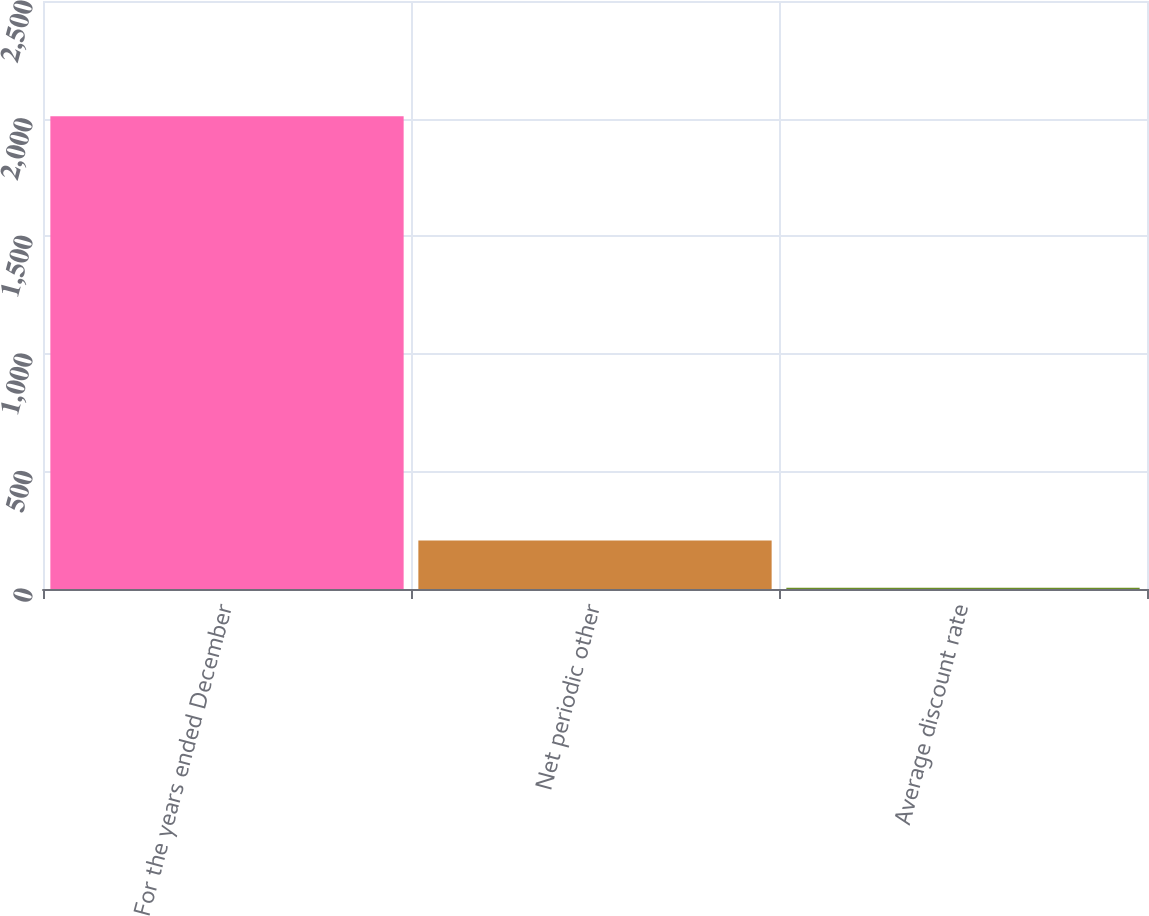Convert chart. <chart><loc_0><loc_0><loc_500><loc_500><bar_chart><fcel>For the years ended December<fcel>Net periodic other<fcel>Average discount rate<nl><fcel>2010<fcel>206.13<fcel>5.7<nl></chart> 